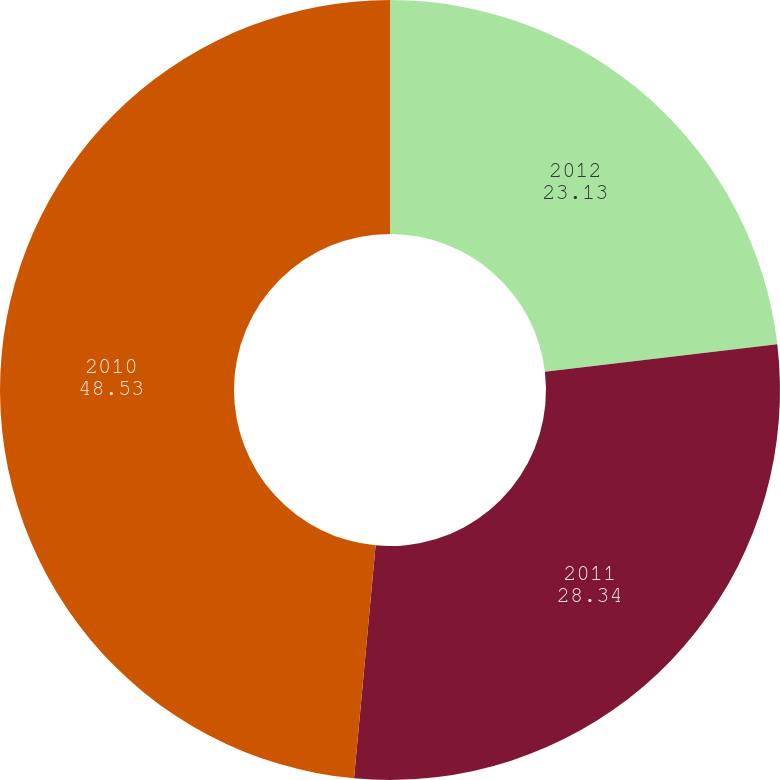Convert chart. <chart><loc_0><loc_0><loc_500><loc_500><pie_chart><fcel>2012<fcel>2011<fcel>2010<nl><fcel>23.13%<fcel>28.34%<fcel>48.53%<nl></chart> 